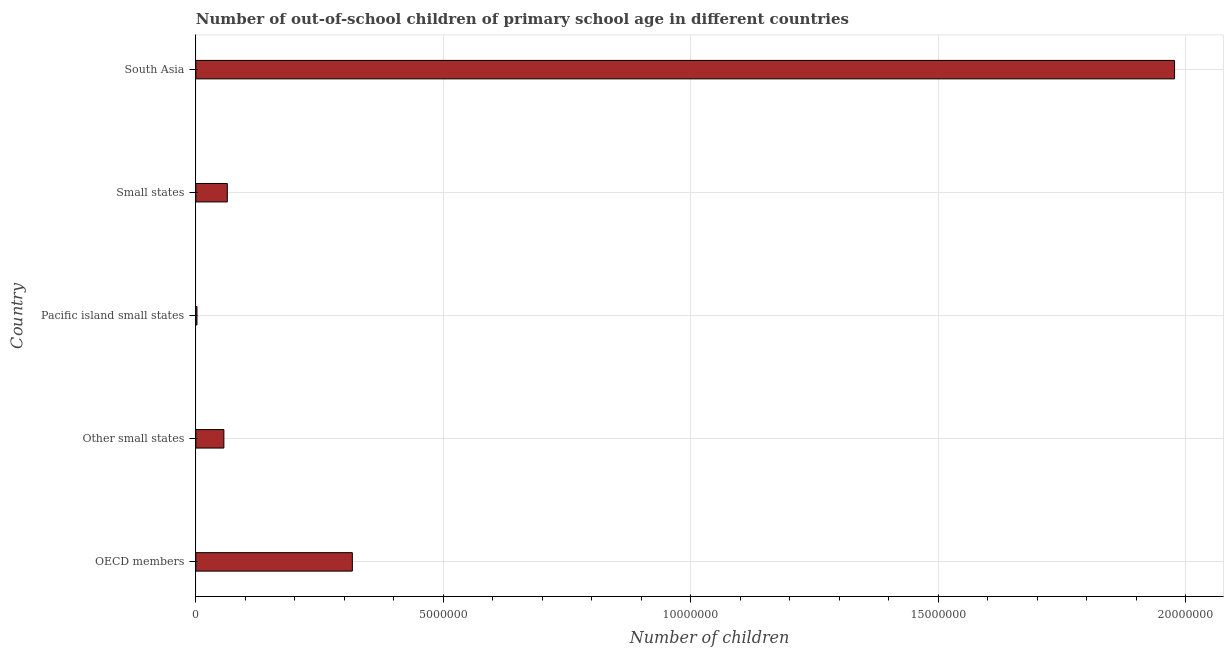What is the title of the graph?
Offer a terse response. Number of out-of-school children of primary school age in different countries. What is the label or title of the X-axis?
Offer a very short reply. Number of children. What is the label or title of the Y-axis?
Your answer should be very brief. Country. What is the number of out-of-school children in Small states?
Provide a short and direct response. 6.36e+05. Across all countries, what is the maximum number of out-of-school children?
Provide a short and direct response. 1.98e+07. Across all countries, what is the minimum number of out-of-school children?
Your answer should be compact. 2.30e+04. In which country was the number of out-of-school children maximum?
Make the answer very short. South Asia. In which country was the number of out-of-school children minimum?
Offer a terse response. Pacific island small states. What is the sum of the number of out-of-school children?
Give a very brief answer. 2.42e+07. What is the difference between the number of out-of-school children in Small states and South Asia?
Your answer should be compact. -1.91e+07. What is the average number of out-of-school children per country?
Ensure brevity in your answer.  4.83e+06. What is the median number of out-of-school children?
Keep it short and to the point. 6.36e+05. What is the ratio of the number of out-of-school children in Other small states to that in Small states?
Keep it short and to the point. 0.89. Is the number of out-of-school children in OECD members less than that in Small states?
Provide a short and direct response. No. Is the difference between the number of out-of-school children in Small states and South Asia greater than the difference between any two countries?
Your response must be concise. No. What is the difference between the highest and the second highest number of out-of-school children?
Offer a very short reply. 1.66e+07. Is the sum of the number of out-of-school children in Other small states and Small states greater than the maximum number of out-of-school children across all countries?
Give a very brief answer. No. What is the difference between the highest and the lowest number of out-of-school children?
Give a very brief answer. 1.98e+07. How many bars are there?
Your response must be concise. 5. How many countries are there in the graph?
Give a very brief answer. 5. What is the difference between two consecutive major ticks on the X-axis?
Make the answer very short. 5.00e+06. Are the values on the major ticks of X-axis written in scientific E-notation?
Offer a terse response. No. What is the Number of children in OECD members?
Your answer should be compact. 3.16e+06. What is the Number of children in Other small states?
Offer a very short reply. 5.67e+05. What is the Number of children of Pacific island small states?
Ensure brevity in your answer.  2.30e+04. What is the Number of children of Small states?
Offer a very short reply. 6.36e+05. What is the Number of children of South Asia?
Your answer should be compact. 1.98e+07. What is the difference between the Number of children in OECD members and Other small states?
Your response must be concise. 2.60e+06. What is the difference between the Number of children in OECD members and Pacific island small states?
Offer a very short reply. 3.14e+06. What is the difference between the Number of children in OECD members and Small states?
Offer a very short reply. 2.53e+06. What is the difference between the Number of children in OECD members and South Asia?
Your answer should be compact. -1.66e+07. What is the difference between the Number of children in Other small states and Pacific island small states?
Make the answer very short. 5.44e+05. What is the difference between the Number of children in Other small states and Small states?
Your answer should be very brief. -6.95e+04. What is the difference between the Number of children in Other small states and South Asia?
Make the answer very short. -1.92e+07. What is the difference between the Number of children in Pacific island small states and Small states?
Give a very brief answer. -6.13e+05. What is the difference between the Number of children in Pacific island small states and South Asia?
Make the answer very short. -1.98e+07. What is the difference between the Number of children in Small states and South Asia?
Ensure brevity in your answer.  -1.91e+07. What is the ratio of the Number of children in OECD members to that in Other small states?
Provide a short and direct response. 5.58. What is the ratio of the Number of children in OECD members to that in Pacific island small states?
Provide a succinct answer. 137.65. What is the ratio of the Number of children in OECD members to that in Small states?
Your response must be concise. 4.97. What is the ratio of the Number of children in OECD members to that in South Asia?
Give a very brief answer. 0.16. What is the ratio of the Number of children in Other small states to that in Pacific island small states?
Ensure brevity in your answer.  24.66. What is the ratio of the Number of children in Other small states to that in Small states?
Give a very brief answer. 0.89. What is the ratio of the Number of children in Other small states to that in South Asia?
Your answer should be compact. 0.03. What is the ratio of the Number of children in Pacific island small states to that in Small states?
Offer a very short reply. 0.04. What is the ratio of the Number of children in Pacific island small states to that in South Asia?
Make the answer very short. 0. What is the ratio of the Number of children in Small states to that in South Asia?
Offer a terse response. 0.03. 